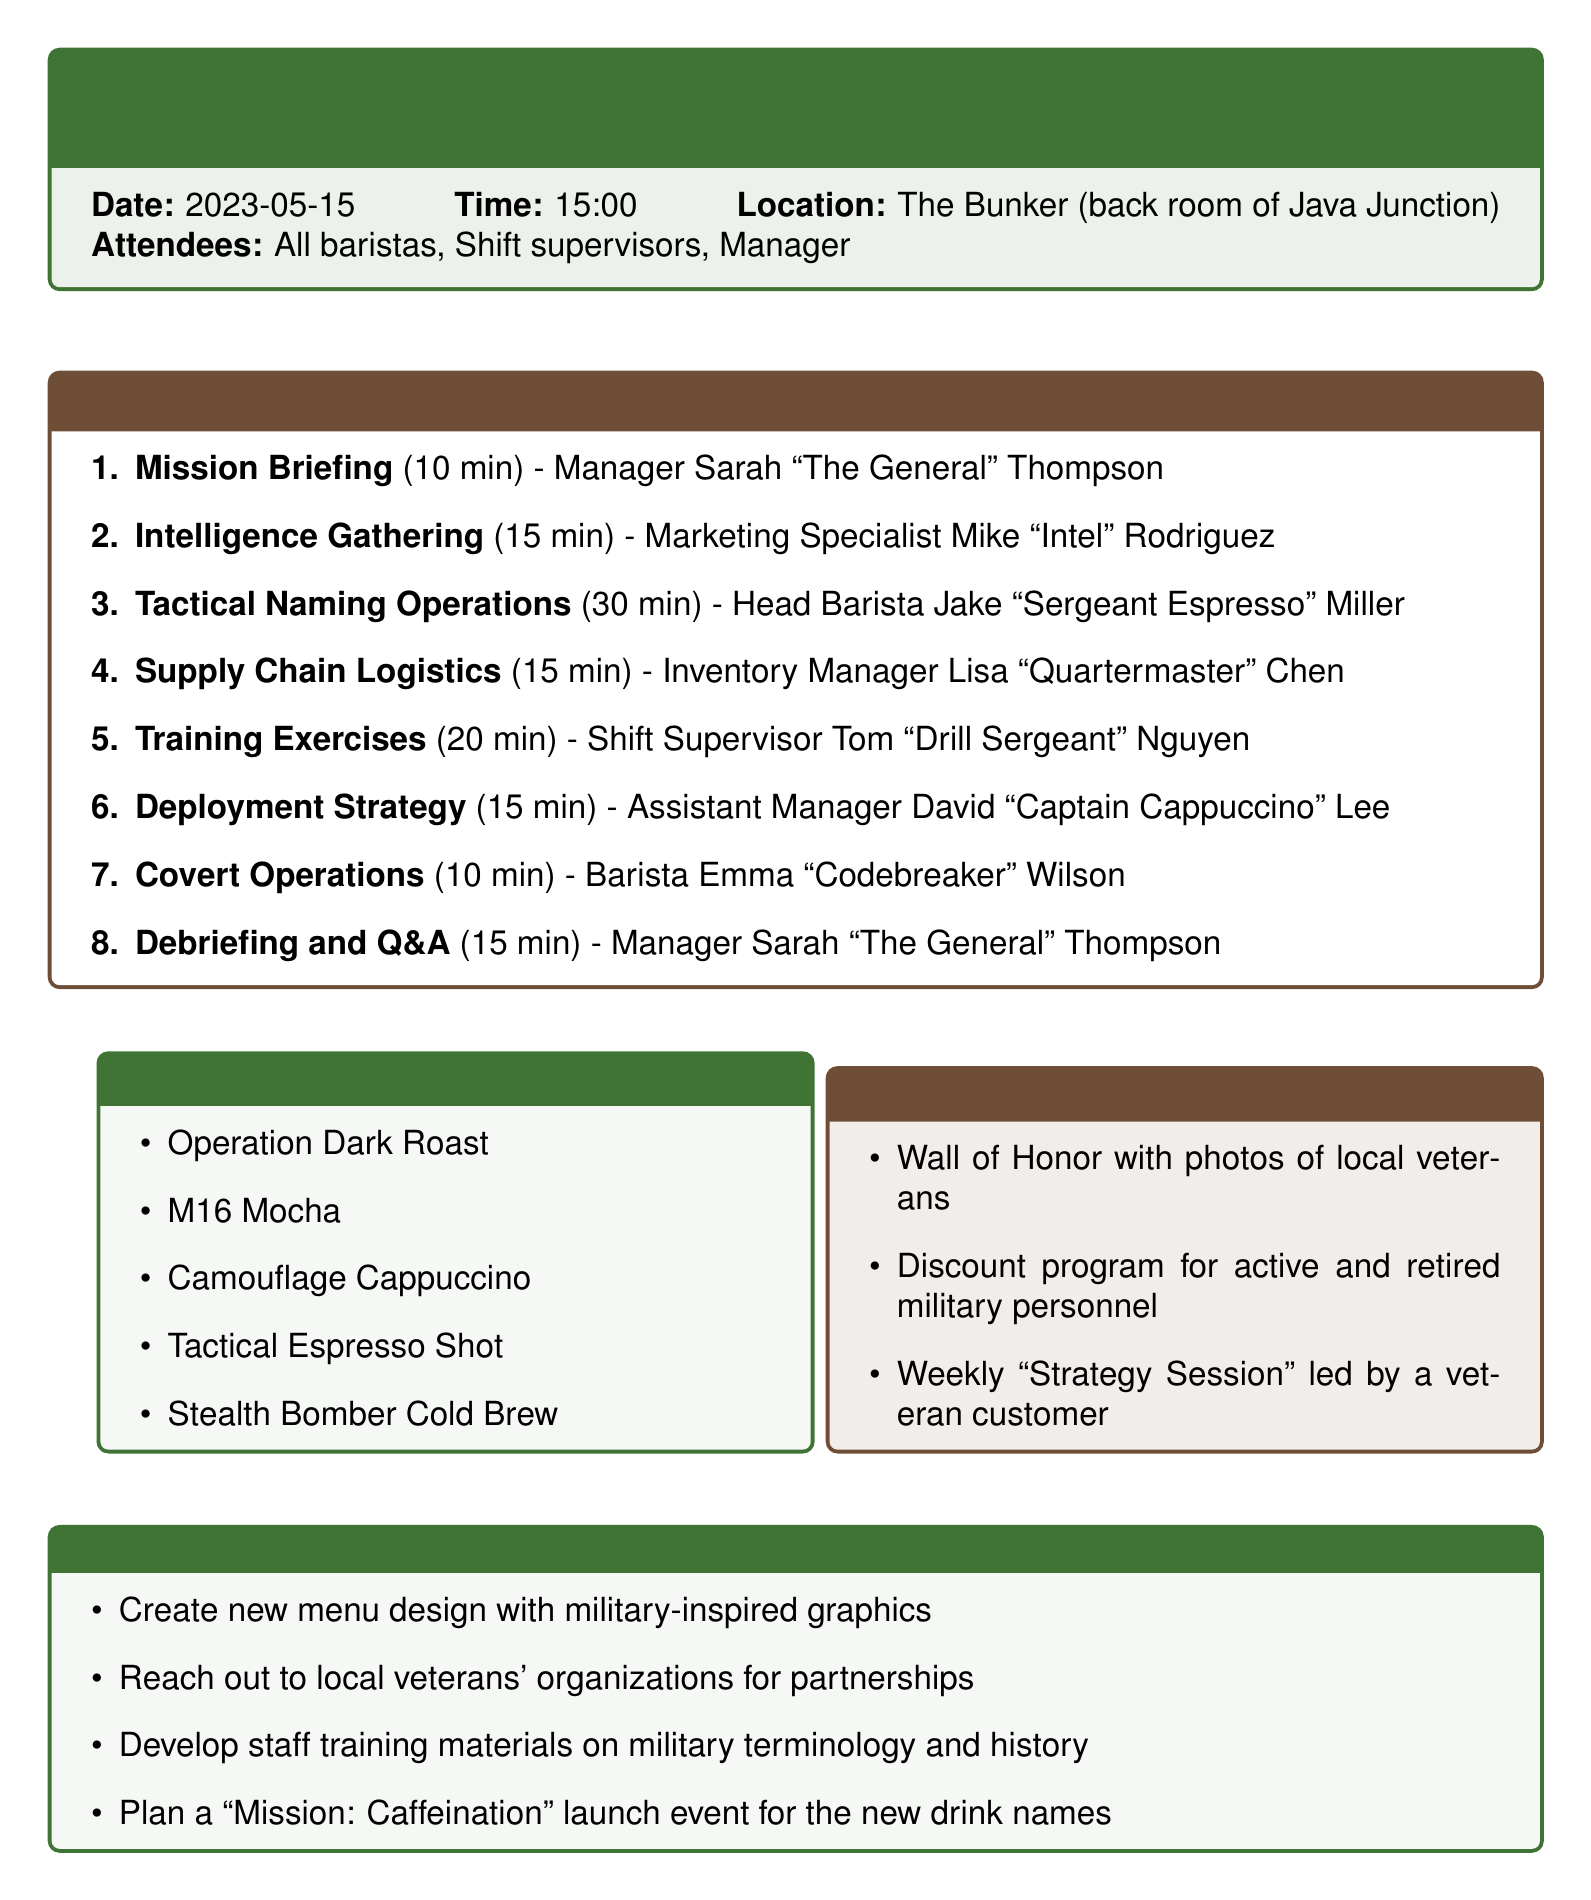What is the title of the meeting? The title of the meeting is stated at the beginning of the document.
Answer: Operation Caffeine Storm: Implementing Military-Inspired Drink Names Who is the presenter for the "Mission Briefing"? The presenter is mentioned alongside the agenda item related to the briefing.
Answer: Manager Sarah 'The General' Thompson What is the duration of the "Tactical Naming Operations"? The duration is specified directly in the agenda section for this item.
Answer: 30 minutes How many proposed drink names are listed in the document? The total number of drink names can be counted in the proposed section.
Answer: 10 What is the focus of "Covert Operations"? The description provides insight into the main topic of this agenda item.
Answer: Discussing potential 'secret menu' items Who leads the "Strategy Session" in the Veterans' Corner? The document indicates the type of person responsible for this specific session.
Answer: A veteran customer What is one of the action items listed in the document? The action items section outlines specific tasks planned after the meeting.
Answer: Create new menu design with military-inspired graphics What time does the meeting start? The starting time is noted alongside the date and location of the meeting.
Answer: 15:00 